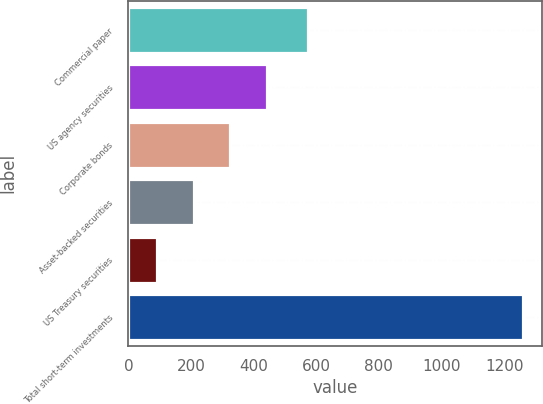Convert chart to OTSL. <chart><loc_0><loc_0><loc_500><loc_500><bar_chart><fcel>Commercial paper<fcel>US agency securities<fcel>Corporate bonds<fcel>Asset-backed securities<fcel>US Treasury securities<fcel>Total short-term investments<nl><fcel>573<fcel>442.1<fcel>325.4<fcel>208.7<fcel>92<fcel>1259<nl></chart> 